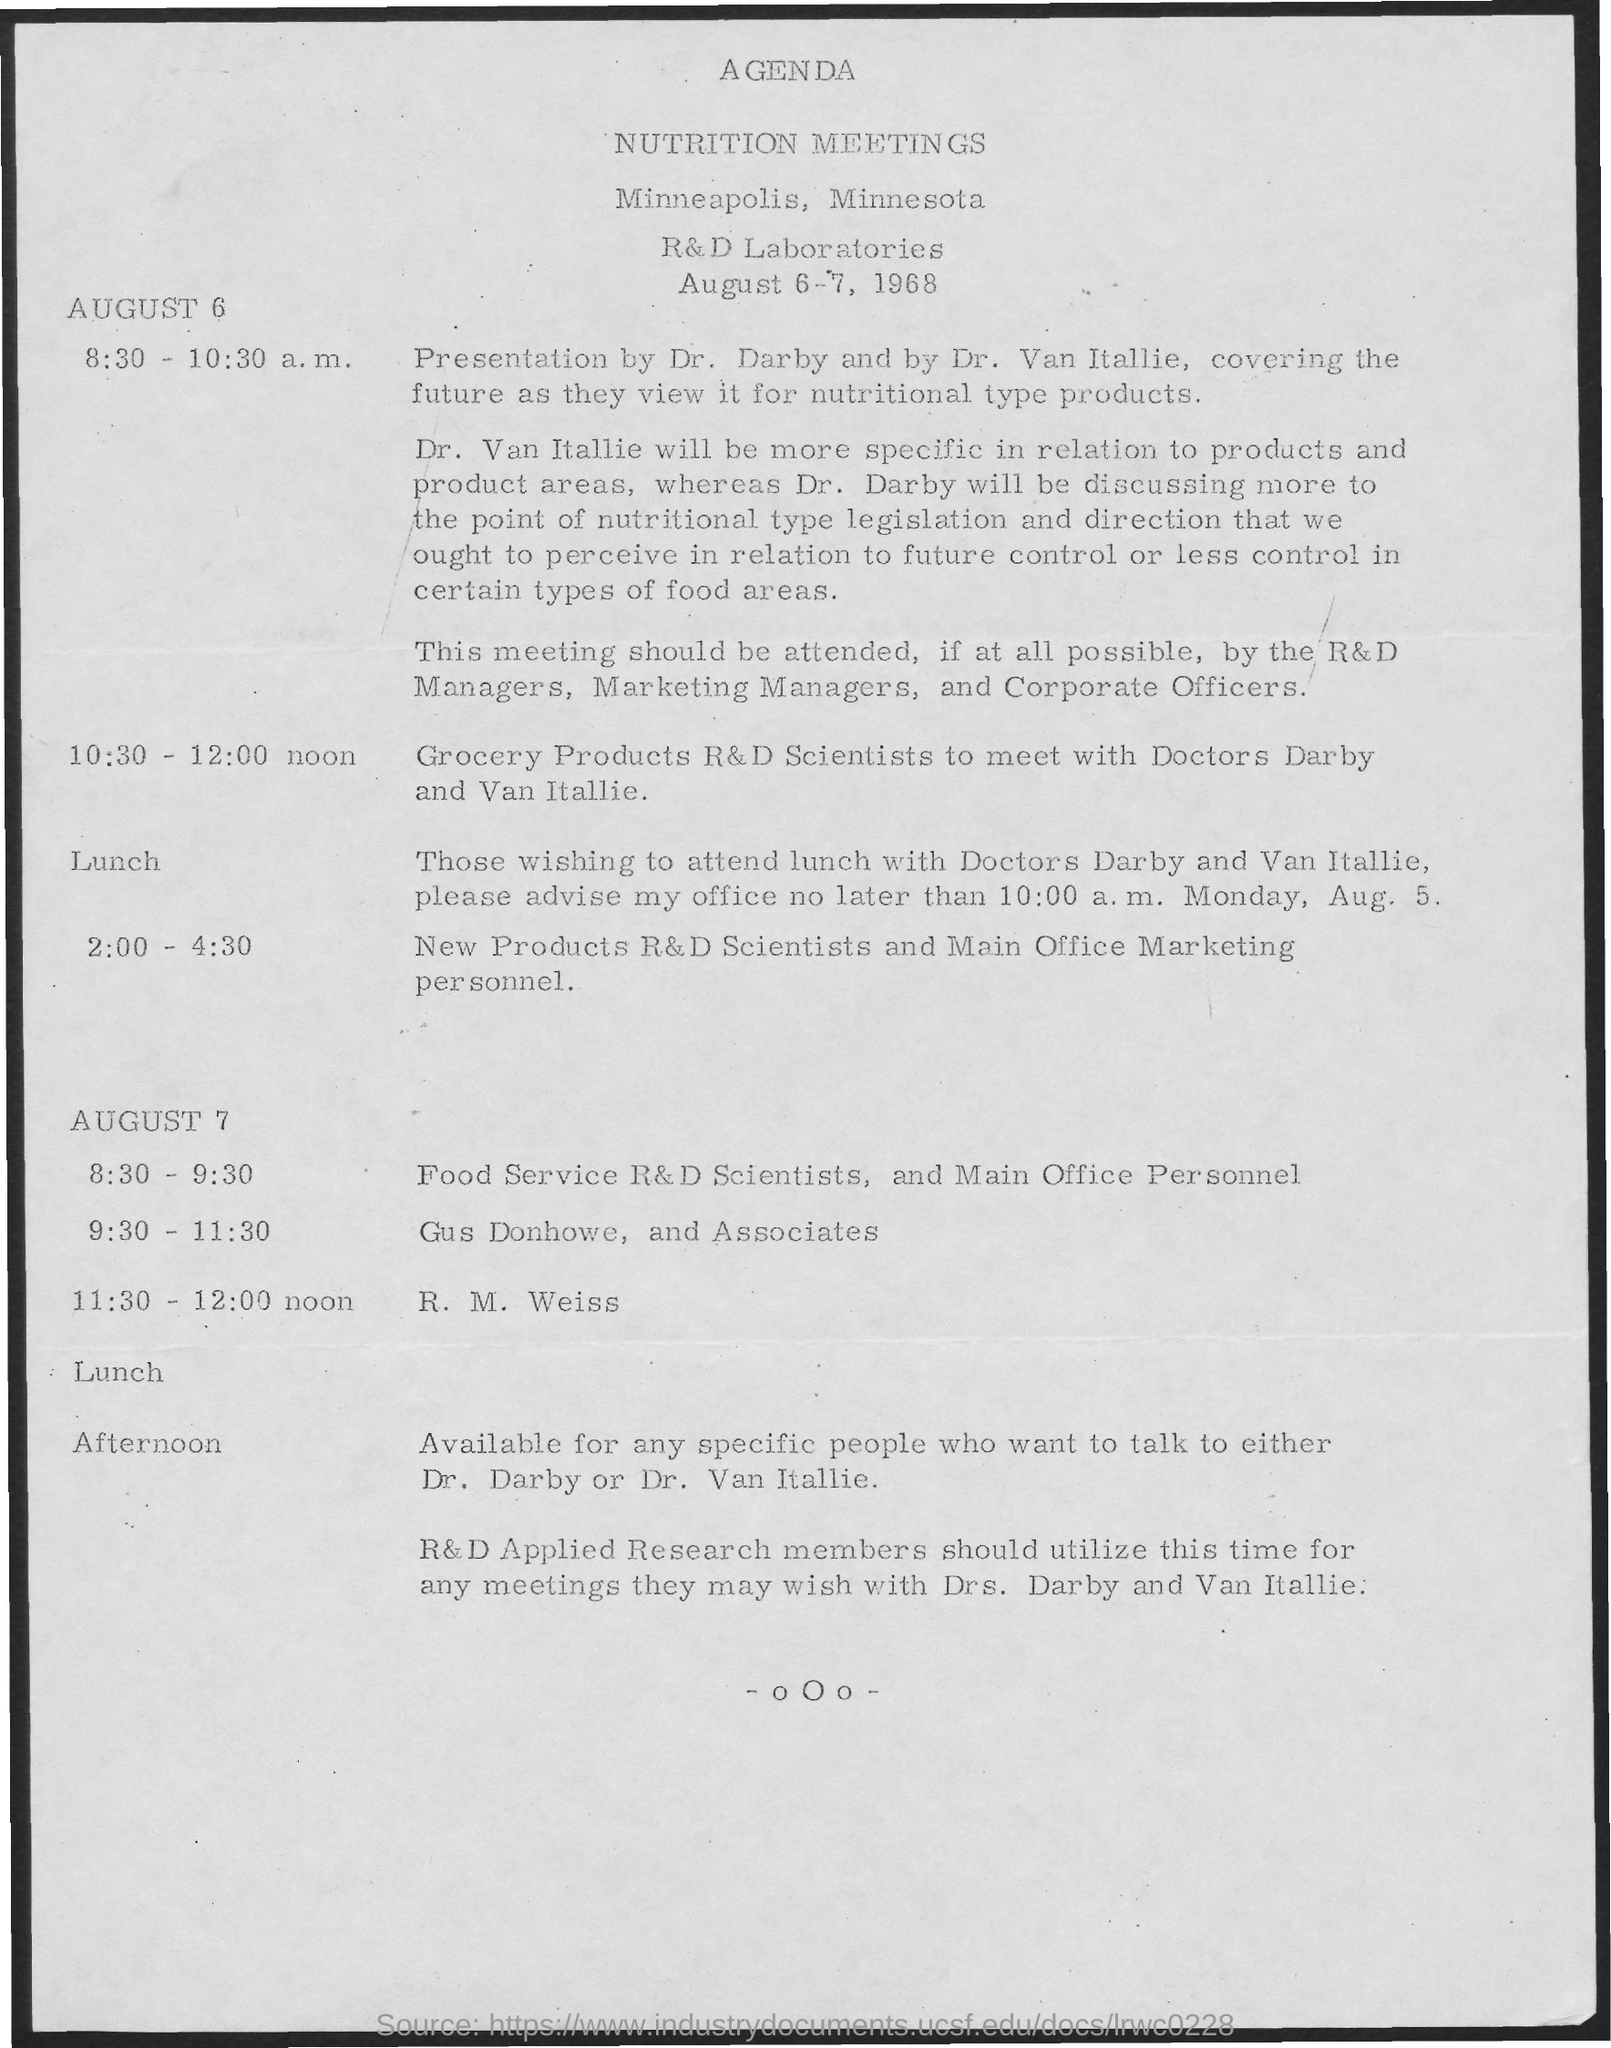What is the schedule at the time of 10:30 - 12:00 noon as mentioned in the given agenda ?
Your answer should be very brief. Grocery products R&D Scientists to meet with Doctors Darby and Van Itallie. What is the schedule at the time of 8:30-9:30 as mentioned in the given agenda ?
Give a very brief answer. Food service r&d scientists , and main office personnel. 